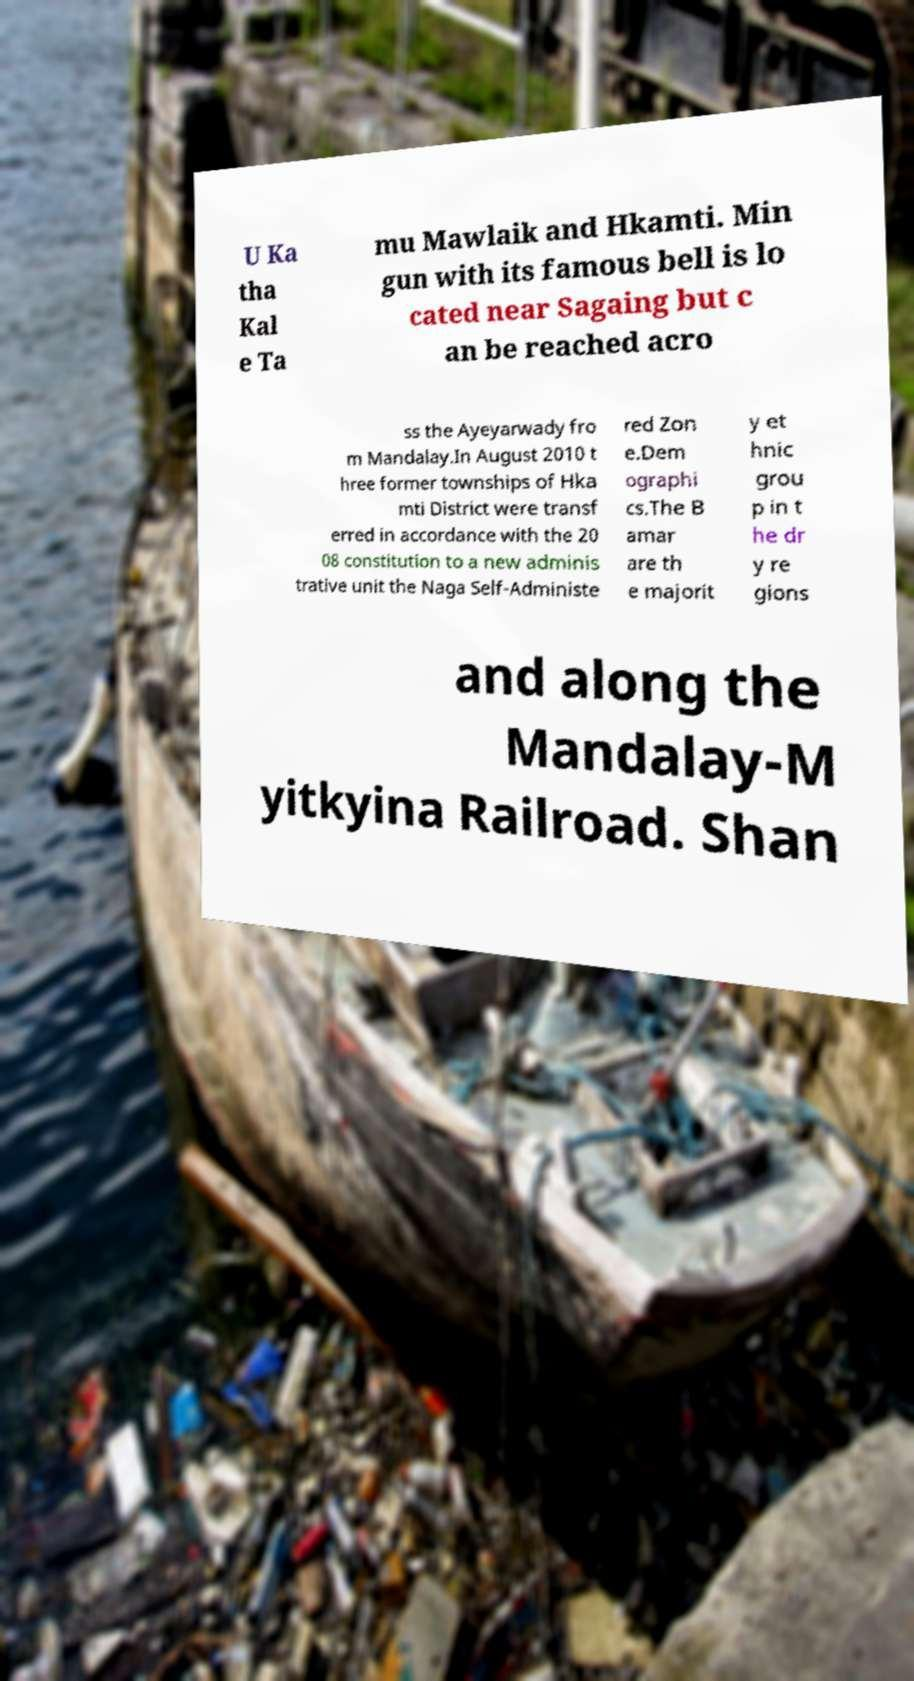Could you assist in decoding the text presented in this image and type it out clearly? U Ka tha Kal e Ta mu Mawlaik and Hkamti. Min gun with its famous bell is lo cated near Sagaing but c an be reached acro ss the Ayeyarwady fro m Mandalay.In August 2010 t hree former townships of Hka mti District were transf erred in accordance with the 20 08 constitution to a new adminis trative unit the Naga Self-Administe red Zon e.Dem ographi cs.The B amar are th e majorit y et hnic grou p in t he dr y re gions and along the Mandalay-M yitkyina Railroad. Shan 